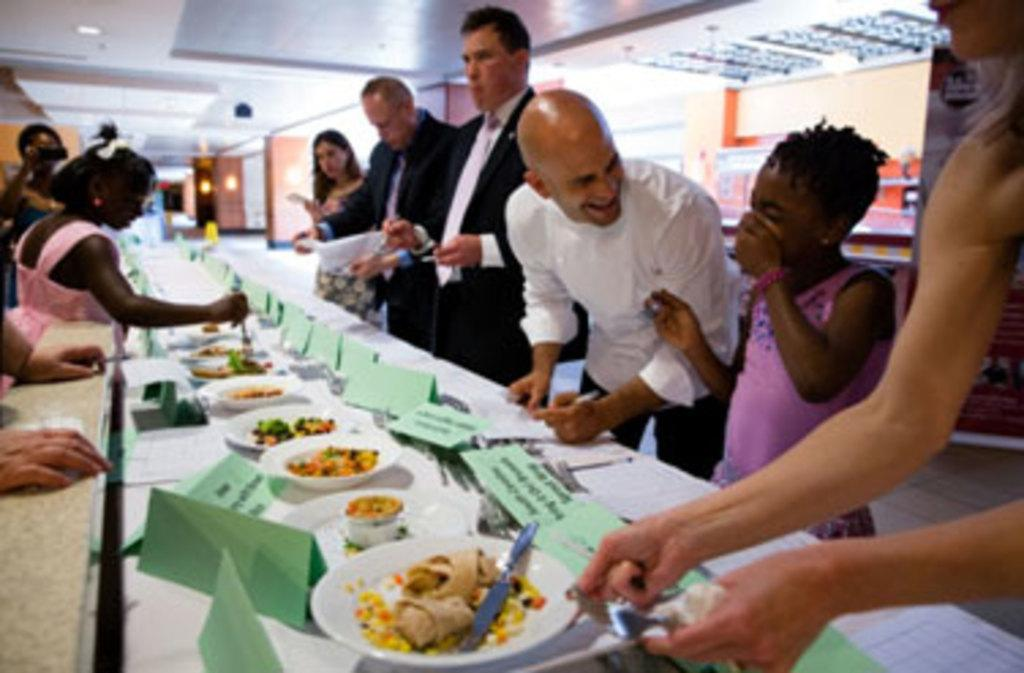What is the main piece of furniture in the image? There is a table in the image. What is placed on the table? There are plates on the table. What is on the plates? There are food items on the plates. How are the people at the table identified? There are name tags on the table. What type of button is being used to read the food items on the plates? There is no button present in the image, and the food items on the plates are not being read. 